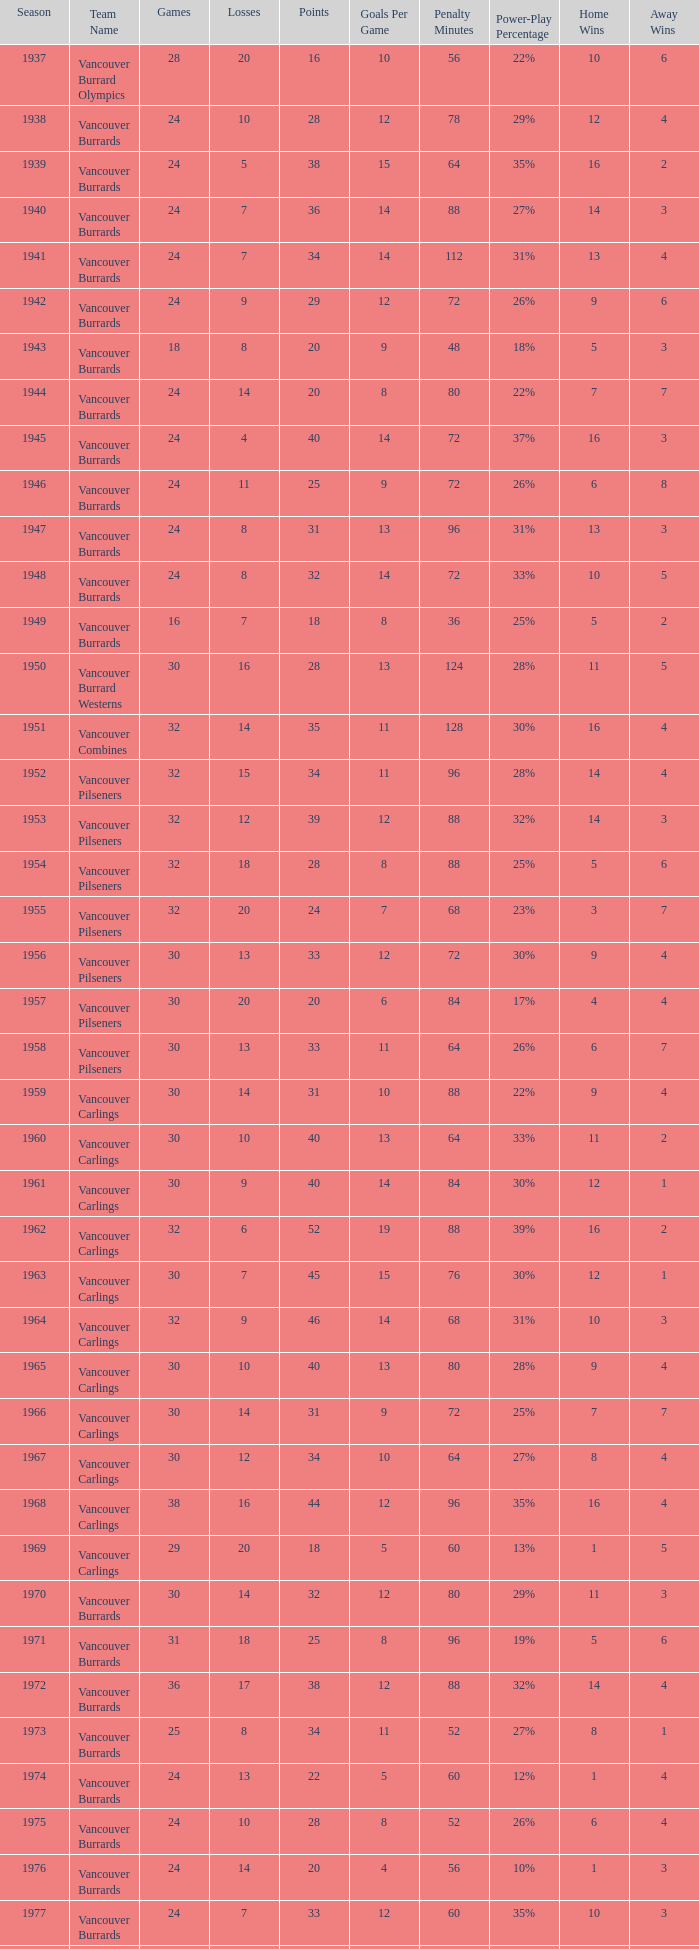What's the total losses for the vancouver burrards in the 1947 season with fewer than 24 games? 0.0. 